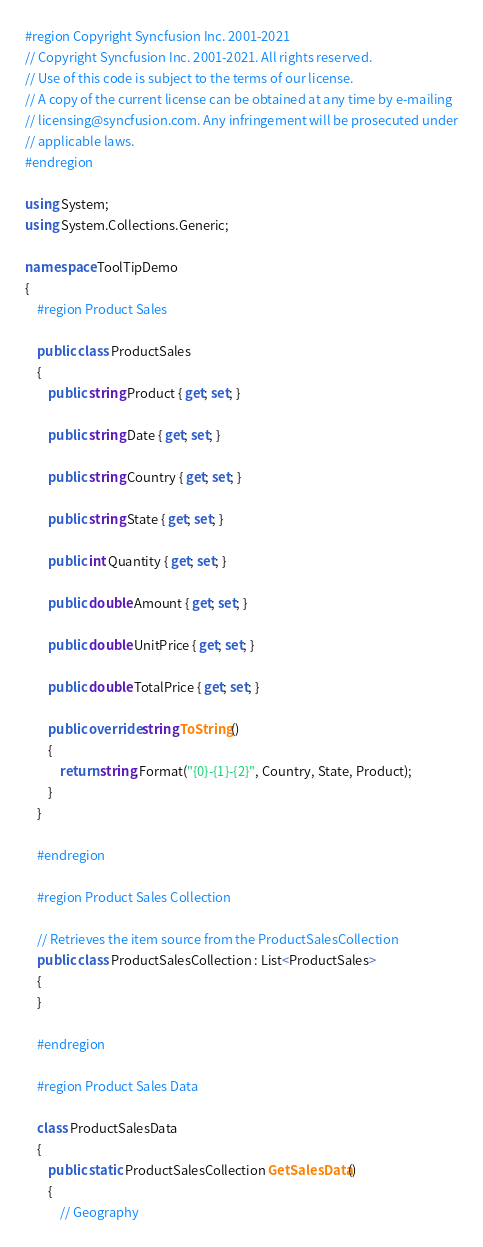Convert code to text. <code><loc_0><loc_0><loc_500><loc_500><_C#_>#region Copyright Syncfusion Inc. 2001-2021
// Copyright Syncfusion Inc. 2001-2021. All rights reserved.
// Use of this code is subject to the terms of our license.
// A copy of the current license can be obtained at any time by e-mailing
// licensing@syncfusion.com. Any infringement will be prosecuted under
// applicable laws. 
#endregion

using System;
using System.Collections.Generic;

namespace ToolTipDemo
{
    #region Product Sales

    public class ProductSales
    {
        public string Product { get; set; }

        public string Date { get; set; }

        public string Country { get; set; }

        public string State { get; set; }

        public int Quantity { get; set; }

        public double Amount { get; set; }

        public double UnitPrice { get; set; }

        public double TotalPrice { get; set; }

        public override string ToString()
        {
            return string.Format("{0}-{1}-{2}", Country, State, Product);
        }
    }

    #endregion

    #region Product Sales Collection

    // Retrieves the item source from the ProductSalesCollection
    public class ProductSalesCollection : List<ProductSales>
    {
    }

    #endregion

    #region Product Sales Data

    class ProductSalesData
    {
        public static ProductSalesCollection GetSalesData()
        {
            // Geography</code> 